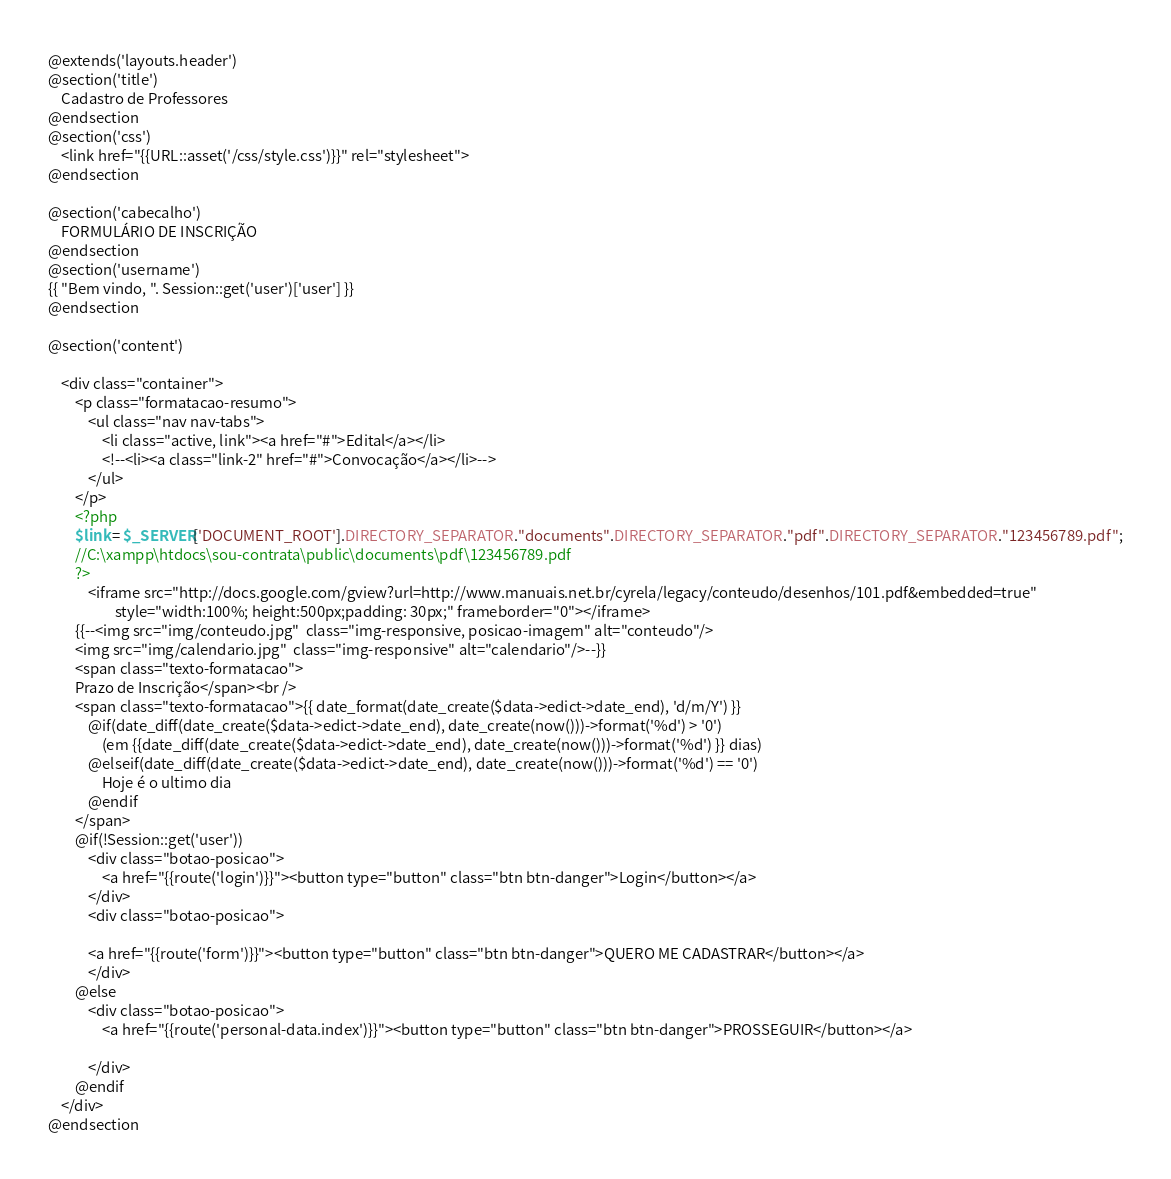<code> <loc_0><loc_0><loc_500><loc_500><_PHP_>@extends('layouts.header')
@section('title')
    Cadastro de Professores
@endsection
@section('css')
    <link href="{{URL::asset('/css/style.css')}}" rel="stylesheet">
@endsection

@section('cabecalho')
    FORMULÁRIO DE INSCRIÇÃO
@endsection
@section('username')
{{ "Bem vindo, ". Session::get('user')['user'] }}
@endsection

@section('content')

    <div class="container">
        <p class="formatacao-resumo">
            <ul class="nav nav-tabs">
                <li class="active, link"><a href="#">Edital</a></li>
                <!--<li><a class="link-2" href="#">Convocação</a></li>-->
            </ul>
        </p>
        <?php
        $link = $_SERVER['DOCUMENT_ROOT'].DIRECTORY_SEPARATOR."documents".DIRECTORY_SEPARATOR."pdf".DIRECTORY_SEPARATOR."123456789.pdf";
        //C:\xampp\htdocs\sou-contrata\public\documents\pdf\123456789.pdf
        ?>
            <iframe src="http://docs.google.com/gview?url=http://www.manuais.net.br/cyrela/legacy/conteudo/desenhos/101.pdf&embedded=true"
                    style="width:100%; height:500px;padding: 30px;" frameborder="0"></iframe>
        {{--<img src="img/conteudo.jpg"  class="img-responsive, posicao-imagem" alt="conteudo"/>
        <img src="img/calendario.jpg"  class="img-responsive" alt="calendario"/>--}}
        <span class="texto-formatacao">
		Prazo de Inscrição</span><br />
        <span class="texto-formatacao">{{ date_format(date_create($data->edict->date_end), 'd/m/Y') }}
            @if(date_diff(date_create($data->edict->date_end), date_create(now()))->format('%d') > '0')
                (em {{date_diff(date_create($data->edict->date_end), date_create(now()))->format('%d') }} dias)
            @elseif(date_diff(date_create($data->edict->date_end), date_create(now()))->format('%d') == '0')
                Hoje é o ultimo dia
            @endif
        </span>
        @if(!Session::get('user'))
            <div class="botao-posicao">
                <a href="{{route('login')}}"><button type="button" class="btn btn-danger">Login</button></a>
            </div>
            <div class="botao-posicao">

            <a href="{{route('form')}}"><button type="button" class="btn btn-danger">QUERO ME CADASTRAR</button></a>
            </div>
        @else
            <div class="botao-posicao">
                <a href="{{route('personal-data.index')}}"><button type="button" class="btn btn-danger">PROSSEGUIR</button></a>

            </div>
        @endif
    </div>
@endsection

</code> 